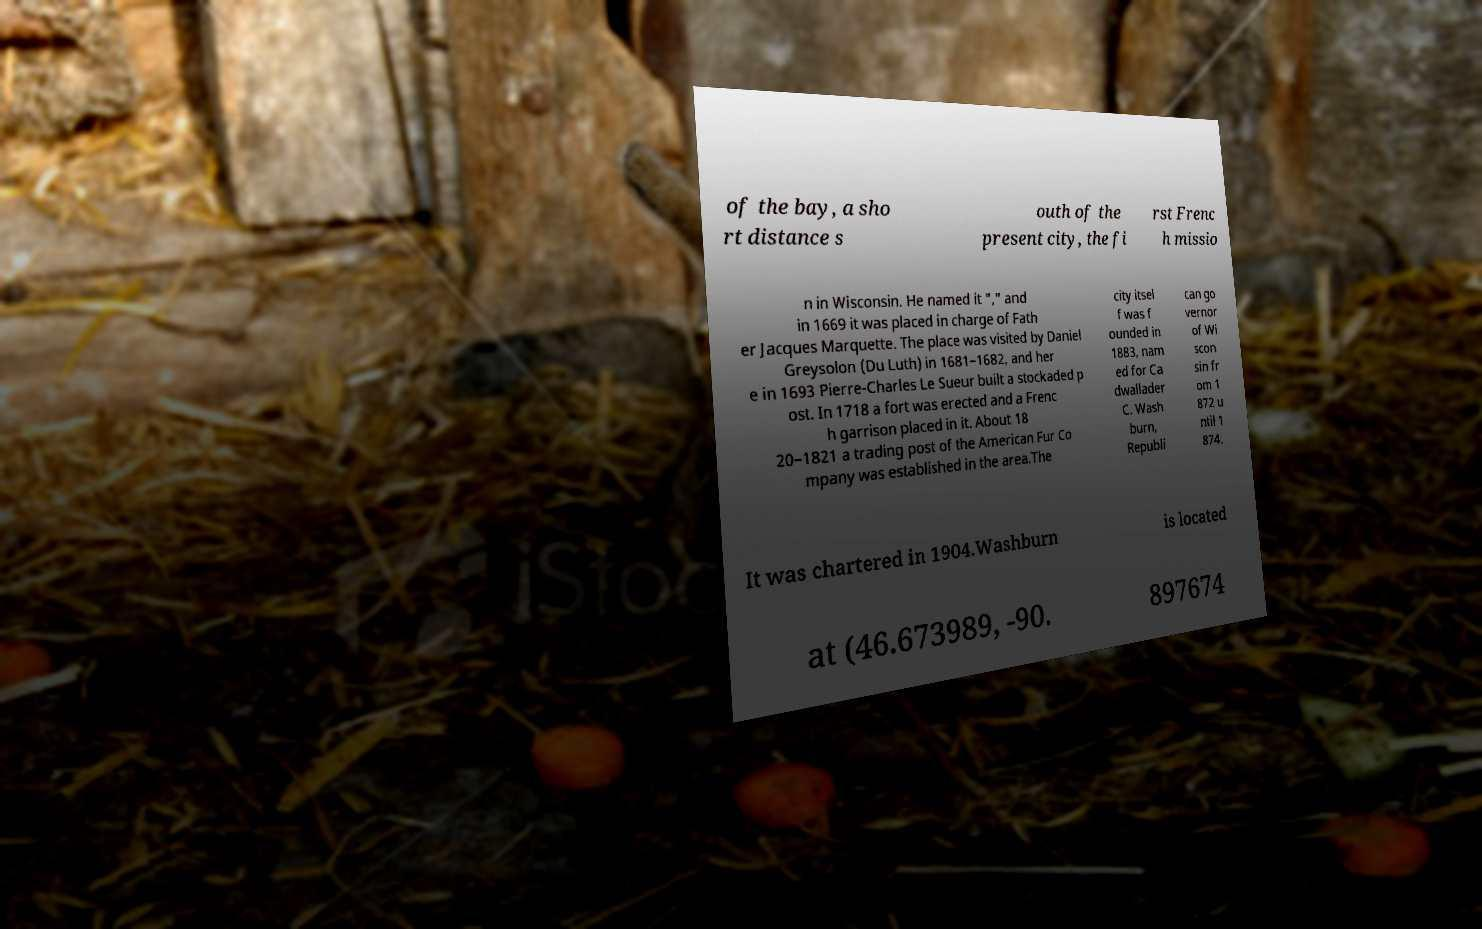I need the written content from this picture converted into text. Can you do that? of the bay, a sho rt distance s outh of the present city, the fi rst Frenc h missio n in Wisconsin. He named it "," and in 1669 it was placed in charge of Fath er Jacques Marquette. The place was visited by Daniel Greysolon (Du Luth) in 1681–1682, and her e in 1693 Pierre-Charles Le Sueur built a stockaded p ost. In 1718 a fort was erected and a Frenc h garrison placed in it. About 18 20–1821 a trading post of the American Fur Co mpany was established in the area.The city itsel f was f ounded in 1883, nam ed for Ca dwallader C. Wash burn, Republi can go vernor of Wi scon sin fr om 1 872 u ntil 1 874. It was chartered in 1904.Washburn is located at (46.673989, -90. 897674 